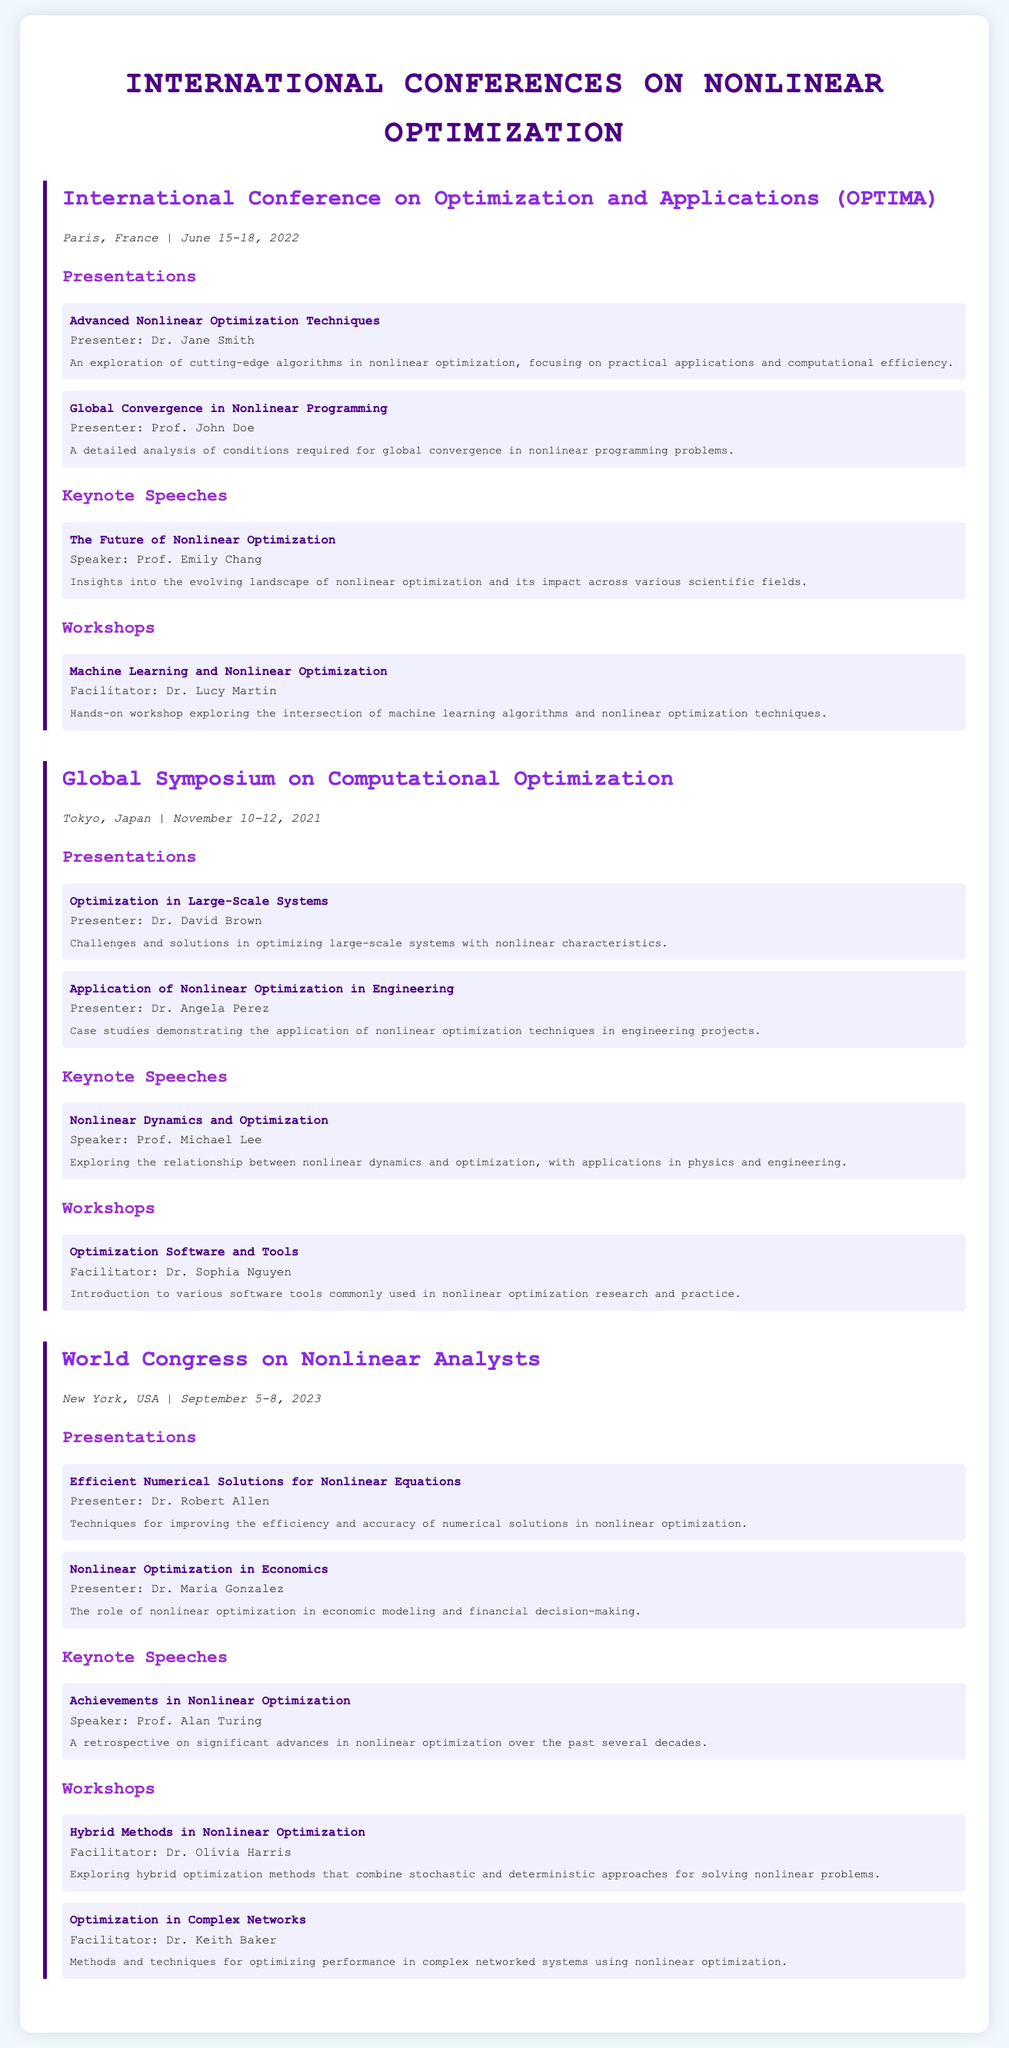what is the location of OPTIMA? The location of the International Conference on Optimization and Applications (OPTIMA) is Paris, France.
Answer: Paris, France who presented "Global Convergence in Nonlinear Programming"? The presenter of the "Global Convergence in Nonlinear Programming" presentation is Prof. John Doe.
Answer: Prof. John Doe what was the date of the World Congress on Nonlinear Analysts? The World Congress on Nonlinear Analysts was held from September 5-8, 2023.
Answer: September 5-8, 2023 who facilitated the workshop on "Hybrid Methods in Nonlinear Optimization"? The facilitator of the workshop on "Hybrid Methods in Nonlinear Optimization" is Dr. Olivia Harris.
Answer: Dr. Olivia Harris what is the title of the keynote speech given by Prof. Alan Turing? The title of the keynote speech given by Prof. Alan Turing is "Achievements in Nonlinear Optimization".
Answer: Achievements in Nonlinear Optimization which city hosted the Global Symposium on Computational Optimization? The Global Symposium on Computational Optimization was hosted in Tokyo, Japan.
Answer: Tokyo, Japan how many presentations were made at the World Congress on Nonlinear Analysts? There were two presentations made at the World Congress on Nonlinear Analysts.
Answer: 2 which workshop topic was related to machine learning? The workshop topic related to machine learning was "Machine Learning and Nonlinear Optimization".
Answer: Machine Learning and Nonlinear Optimization 